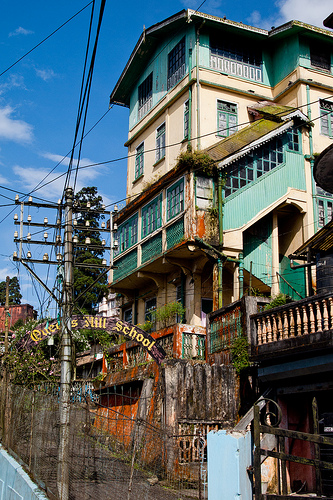<image>
Is the pole next to the school? Yes. The pole is positioned adjacent to the school, located nearby in the same general area. 